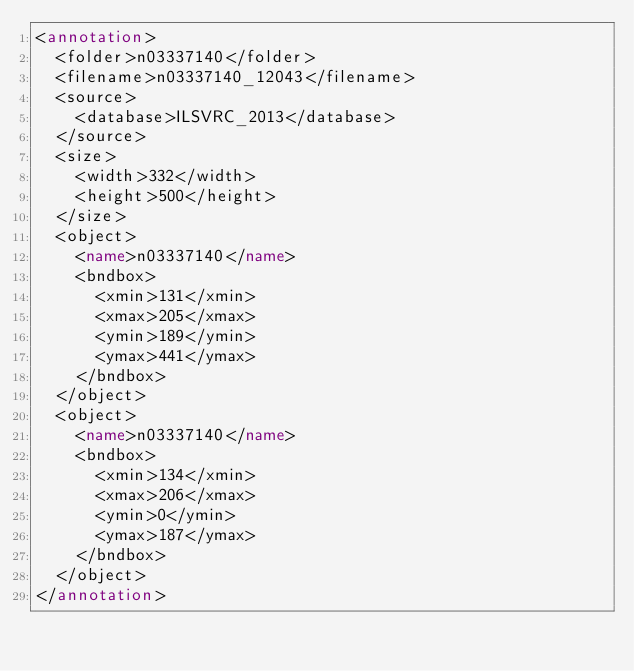Convert code to text. <code><loc_0><loc_0><loc_500><loc_500><_XML_><annotation>
	<folder>n03337140</folder>
	<filename>n03337140_12043</filename>
	<source>
		<database>ILSVRC_2013</database>
	</source>
	<size>
		<width>332</width>
		<height>500</height>
	</size>
	<object>
		<name>n03337140</name>
		<bndbox>
			<xmin>131</xmin>
			<xmax>205</xmax>
			<ymin>189</ymin>
			<ymax>441</ymax>
		</bndbox>
	</object>
	<object>
		<name>n03337140</name>
		<bndbox>
			<xmin>134</xmin>
			<xmax>206</xmax>
			<ymin>0</ymin>
			<ymax>187</ymax>
		</bndbox>
	</object>
</annotation>
</code> 